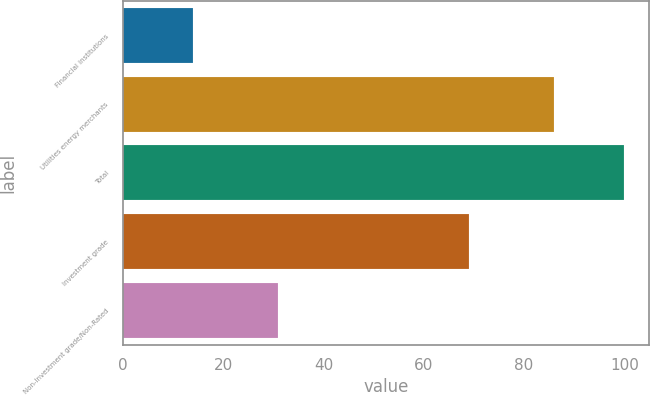Convert chart. <chart><loc_0><loc_0><loc_500><loc_500><bar_chart><fcel>Financial institutions<fcel>Utilities energy merchants<fcel>Total<fcel>Investment grade<fcel>Non-Investment grade/Non-Rated<nl><fcel>14<fcel>86<fcel>100<fcel>69<fcel>31<nl></chart> 